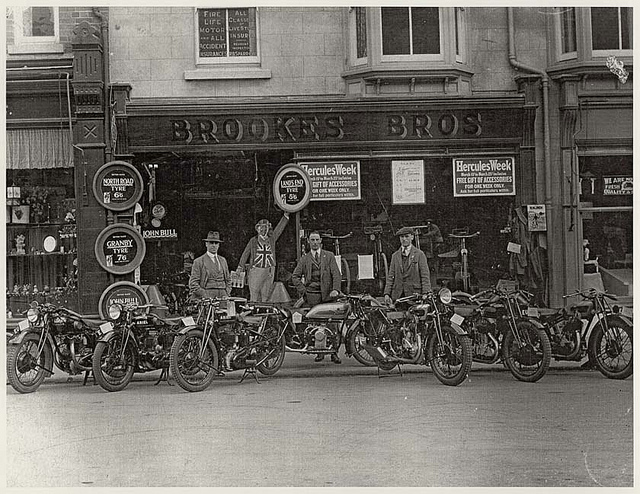Extract all visible text content from this image. BROOKES LIFE Herculesweek BROS ALL 70 